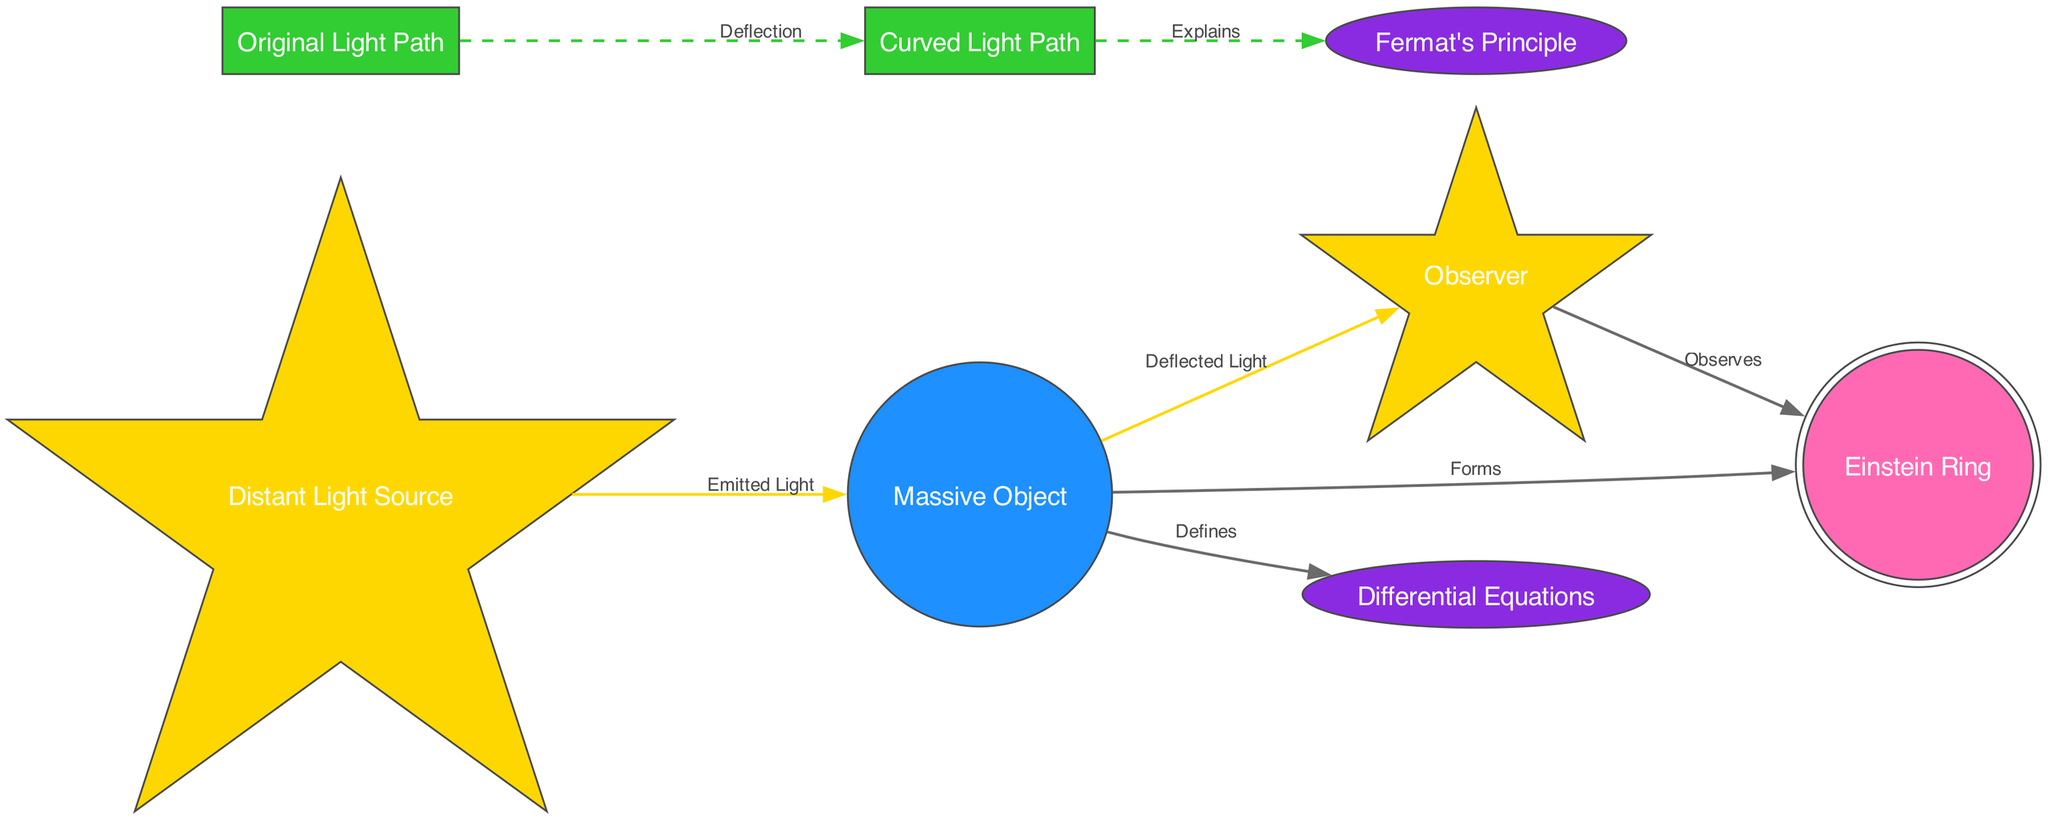What is the label of the node representing the massive object? The node representing the massive object is labeled "Massive Object."
Answer: Massive Object How many edges are connected to the lens object? The lens object has four edges coming from it toward the observer, Einstein Ring, light paths, and differential equations.
Answer: Four What does the observer observe in the diagram? The observer observes the Einstein Ring as indicated by the edge labeled "Observes."
Answer: Einstein Ring Which principle explains the curved light path in the diagram? The curved light path is explained by Fermat's Principle, as detailed in the edge leading from light_path_curved to fermat_principle.
Answer: Fermat's Principle Describe the relationship between the original light path and the curved light path. The relationship is indicated by the edge labeled "Deflection," which signifies the change in light direction due to gravitational influence from the massive object.
Answer: Change in light direction What defines the curvature of spacetime in this diagram? The curvature of spacetime is defined by the differential equations, as shown by the edge from lens_object to differential_equations.
Answer: Differential equations What structure forms as a result of the curved light paths? The curved light paths converge to form the Einstein Ring, which is depicted in the diagram.
Answer: Einstein Ring What is the purpose of the node labeled "Distant Light Source"? The purpose of the Distant Light Source node is to represent a star or galaxy that is emitting light towards the massive object.
Answer: Emitting light Explain the significance of the edge labeled "Forms." The edge labeled "Forms" signifies that the curved light paths are converging to create a distinct visual structure known as the Einstein Ring, illustrating the outcome of gravitational lensing.
Answer: Creation of Einstein Ring 